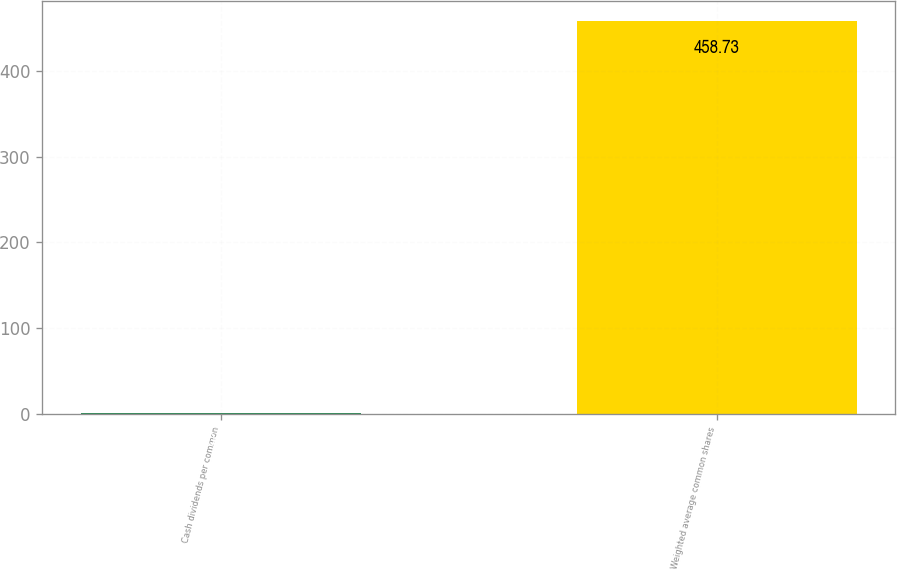<chart> <loc_0><loc_0><loc_500><loc_500><bar_chart><fcel>Cash dividends per common<fcel>Weighted average common shares<nl><fcel>0.67<fcel>458.73<nl></chart> 